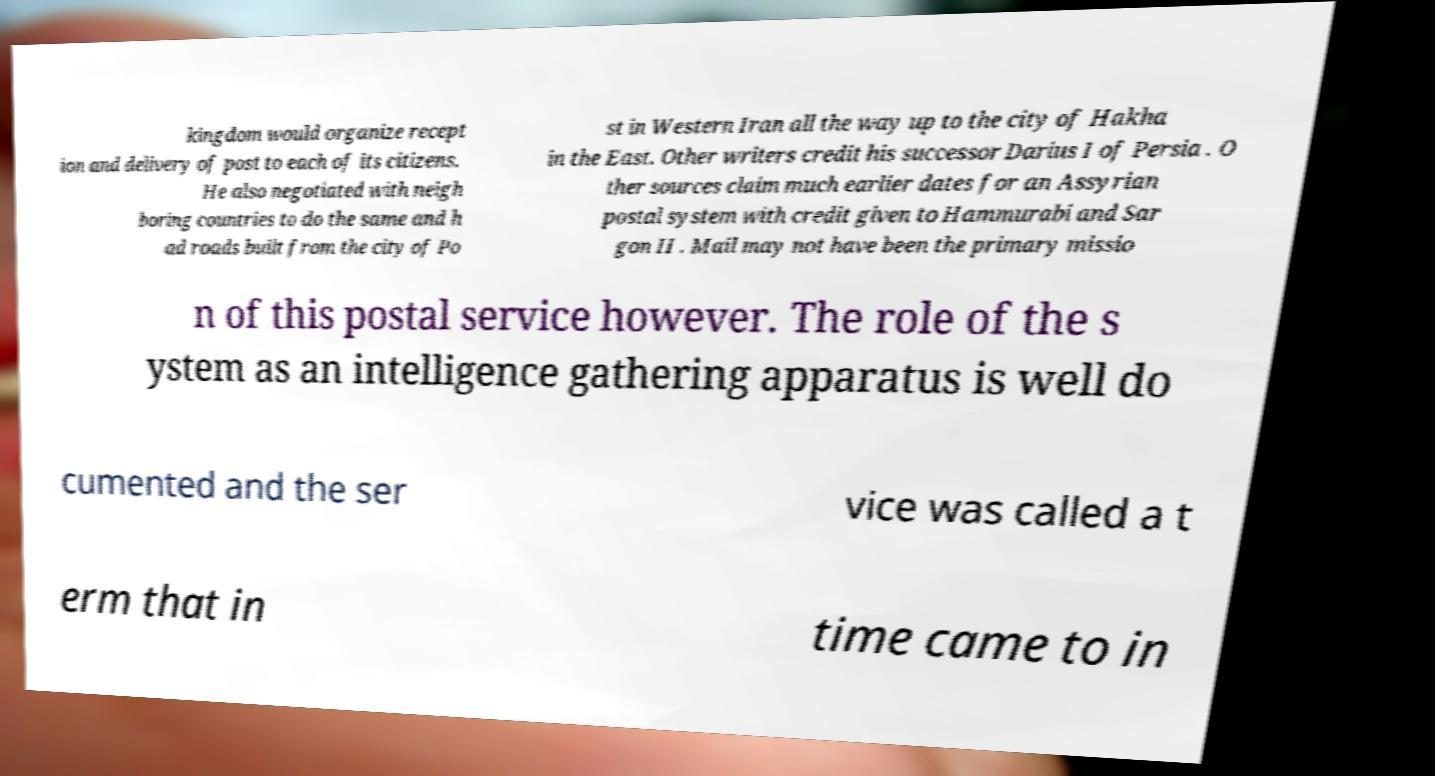What messages or text are displayed in this image? I need them in a readable, typed format. kingdom would organize recept ion and delivery of post to each of its citizens. He also negotiated with neigh boring countries to do the same and h ad roads built from the city of Po st in Western Iran all the way up to the city of Hakha in the East. Other writers credit his successor Darius I of Persia . O ther sources claim much earlier dates for an Assyrian postal system with credit given to Hammurabi and Sar gon II . Mail may not have been the primary missio n of this postal service however. The role of the s ystem as an intelligence gathering apparatus is well do cumented and the ser vice was called a t erm that in time came to in 